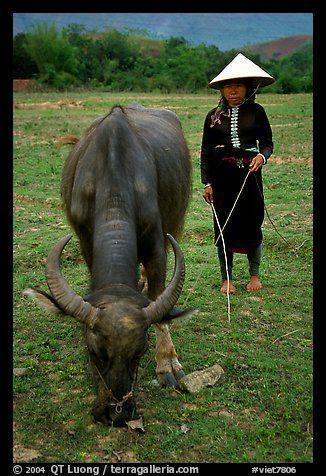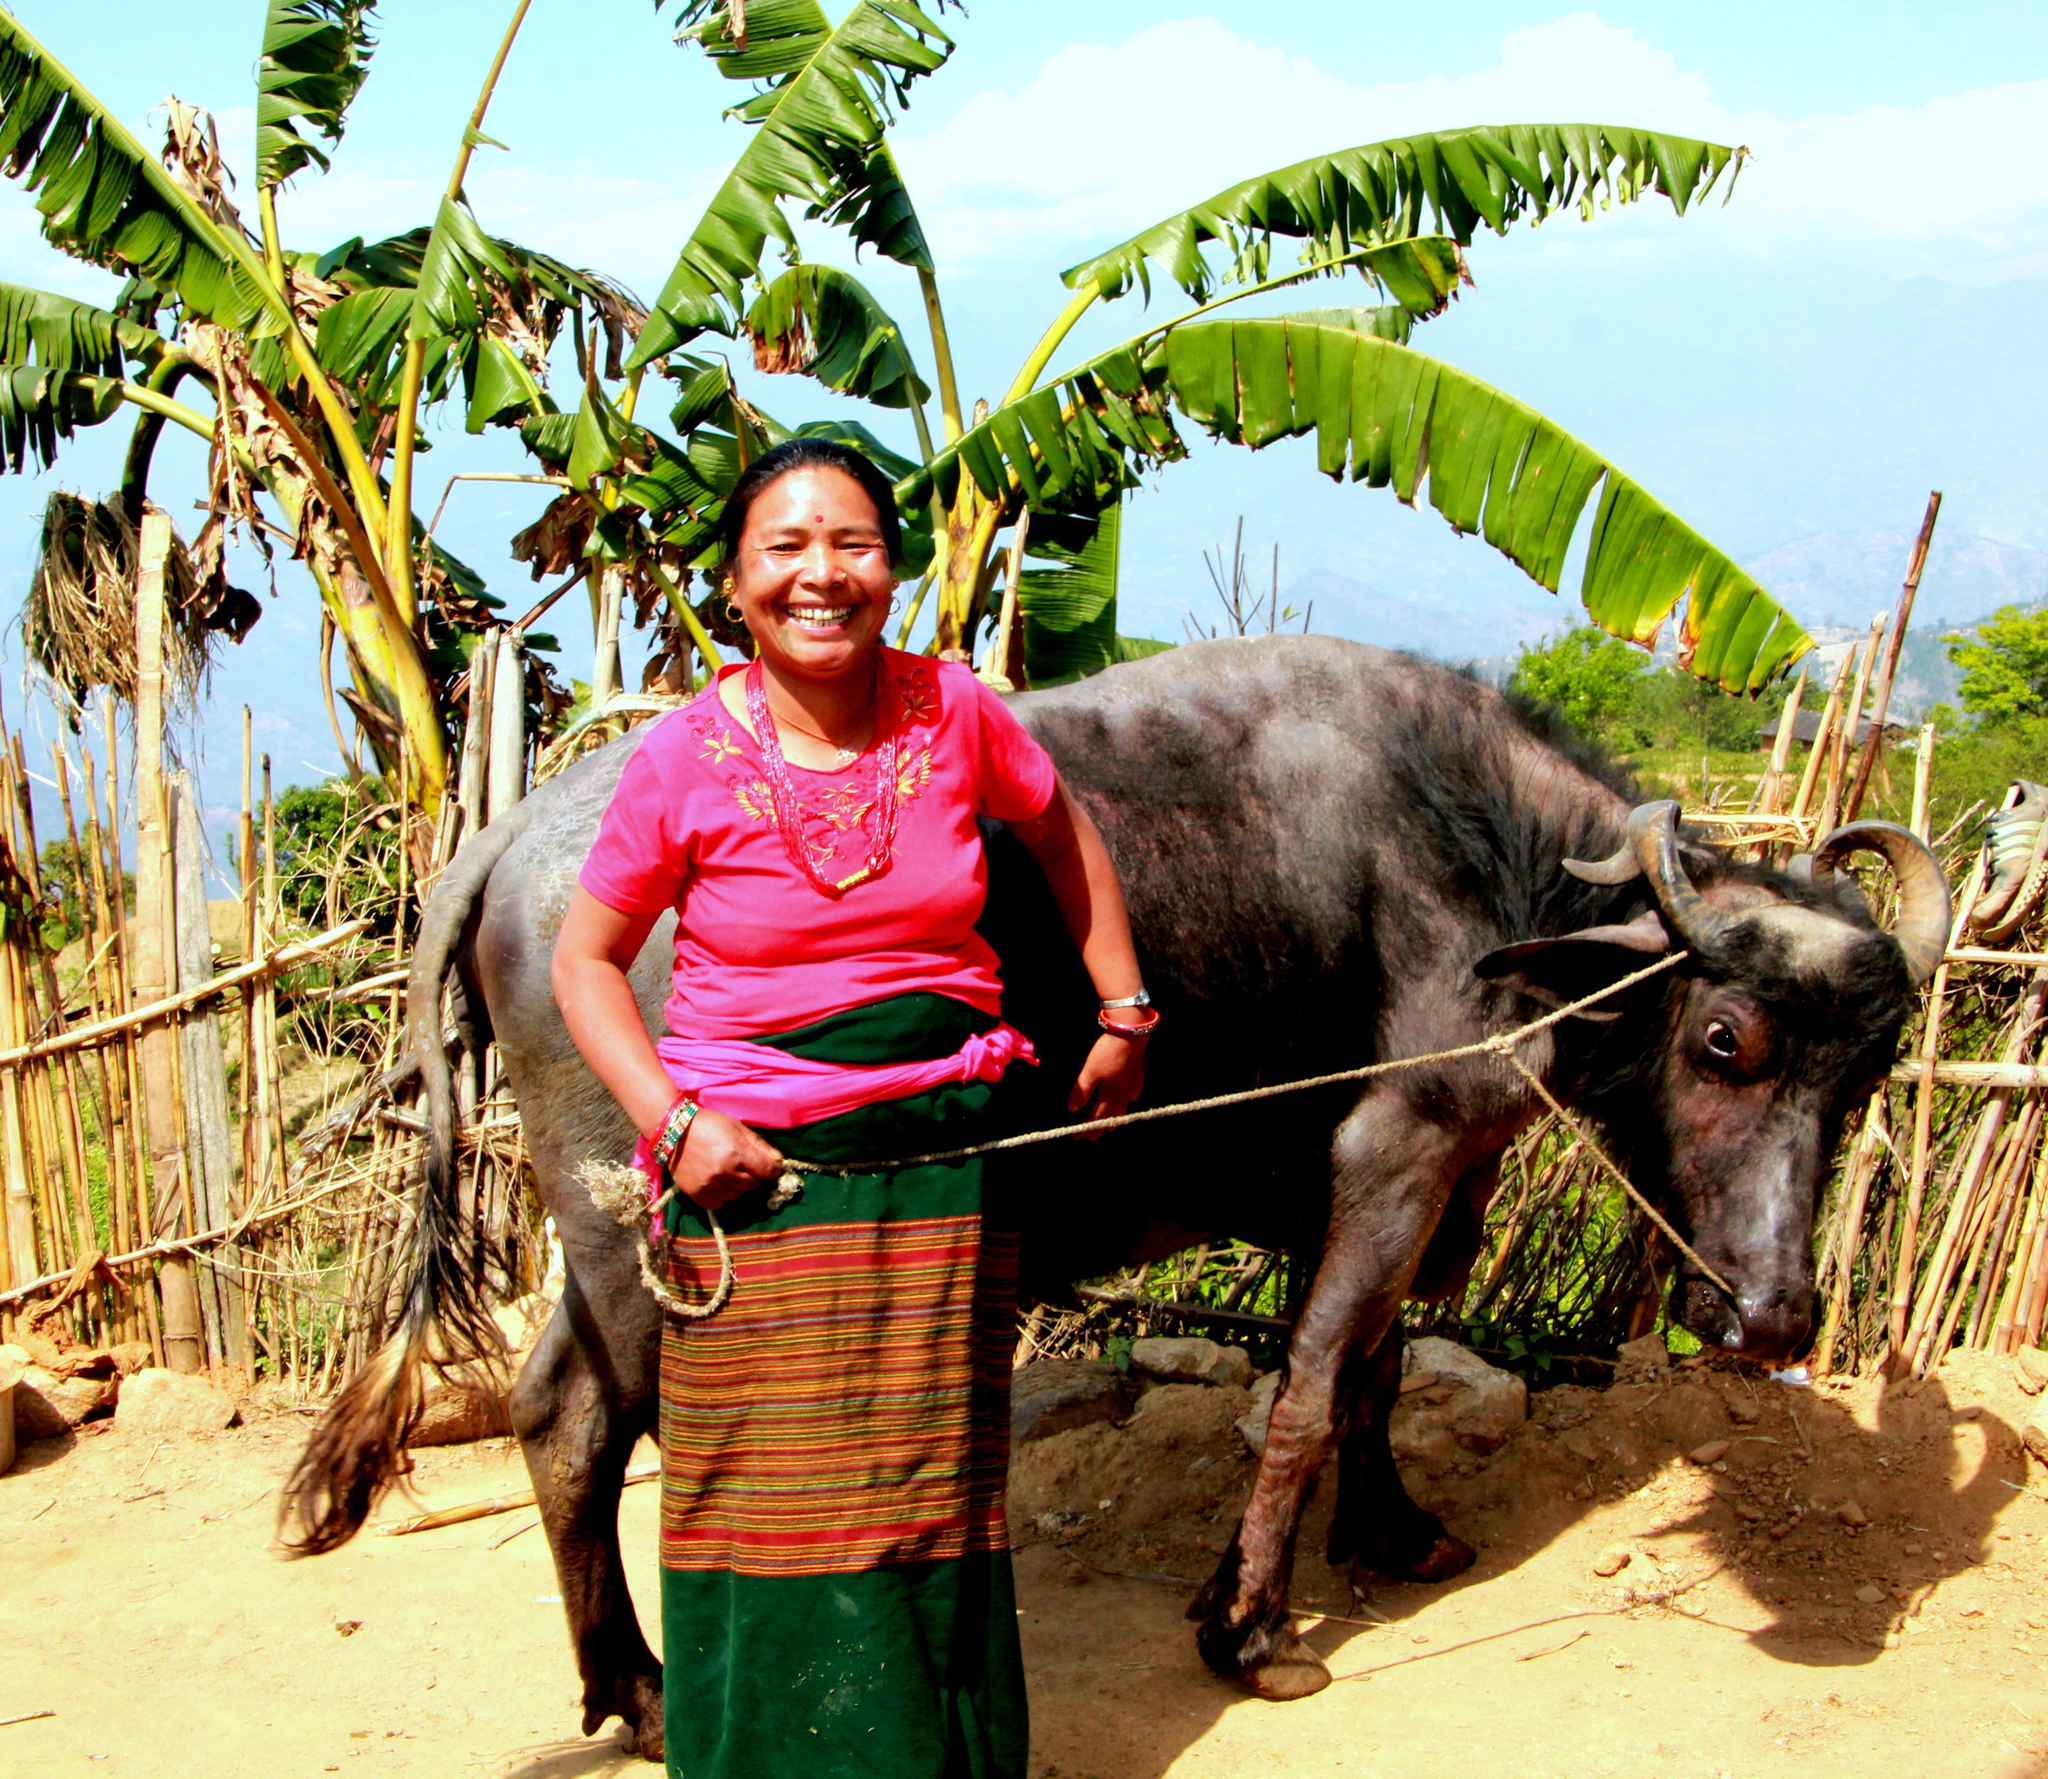The first image is the image on the left, the second image is the image on the right. For the images displayed, is the sentence "There is exactly one person riding a water buffalo in each image." factually correct? Answer yes or no. No. The first image is the image on the left, the second image is the image on the right. For the images displayed, is the sentence "There are exactly two people riding on animals." factually correct? Answer yes or no. No. 